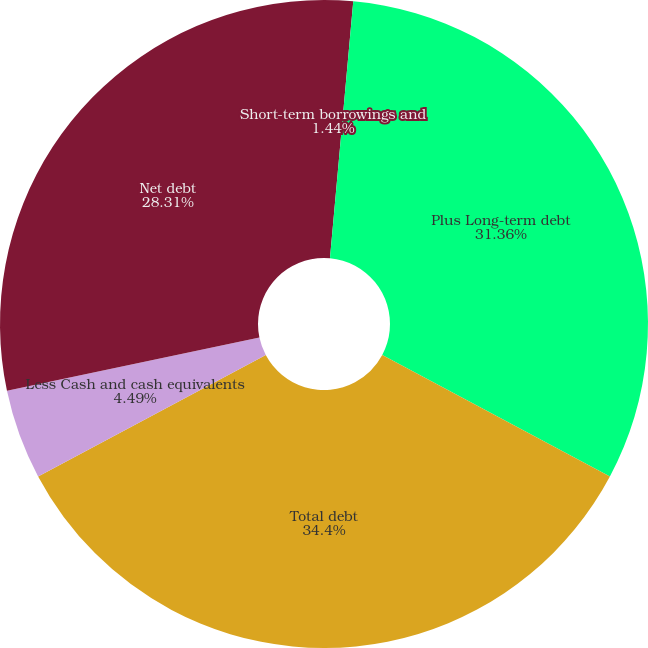<chart> <loc_0><loc_0><loc_500><loc_500><pie_chart><fcel>Short-term borrowings and<fcel>Plus Long-term debt<fcel>Total debt<fcel>Less Cash and cash equivalents<fcel>Net debt<nl><fcel>1.44%<fcel>31.36%<fcel>34.41%<fcel>4.49%<fcel>28.31%<nl></chart> 